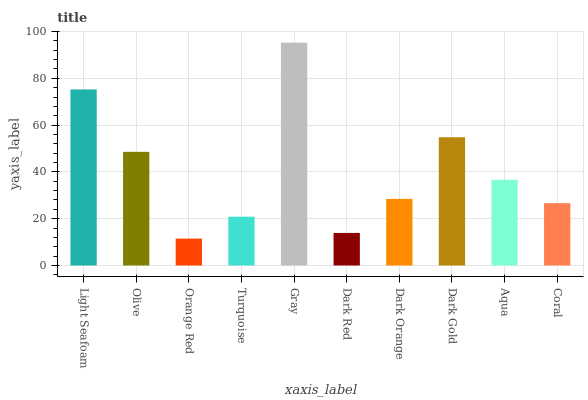Is Olive the minimum?
Answer yes or no. No. Is Olive the maximum?
Answer yes or no. No. Is Light Seafoam greater than Olive?
Answer yes or no. Yes. Is Olive less than Light Seafoam?
Answer yes or no. Yes. Is Olive greater than Light Seafoam?
Answer yes or no. No. Is Light Seafoam less than Olive?
Answer yes or no. No. Is Aqua the high median?
Answer yes or no. Yes. Is Dark Orange the low median?
Answer yes or no. Yes. Is Light Seafoam the high median?
Answer yes or no. No. Is Dark Red the low median?
Answer yes or no. No. 